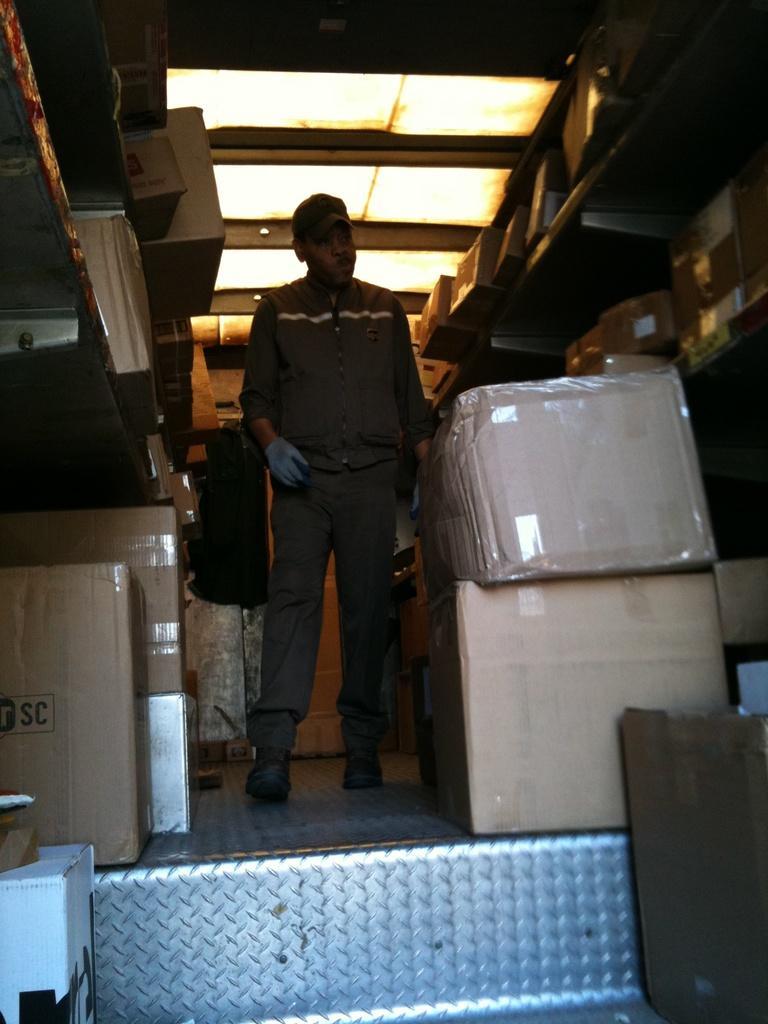Can you describe this image briefly? In this picture I can see a man standing in front and I can see number of boxes around him. On the top of this picture I can see the lights and I see that he is standing on the silver color surface. 